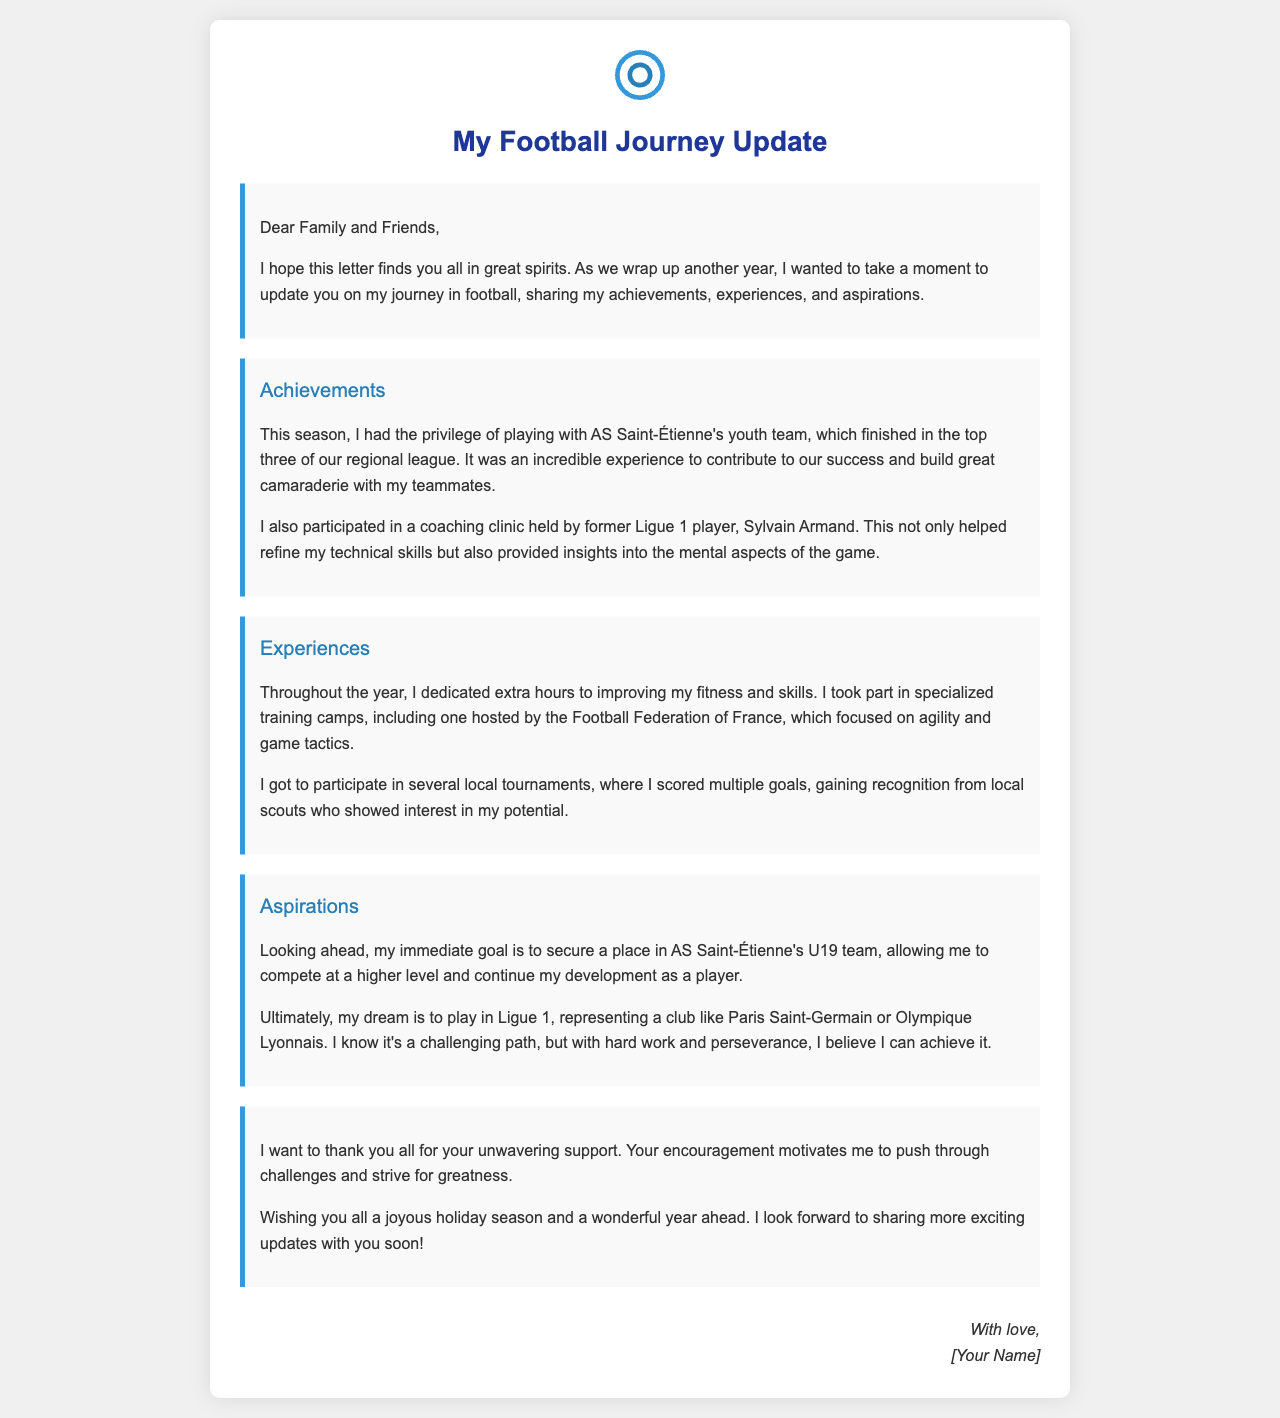What team did you play with this season? The document states that the writer played with AS Saint-Étienne's youth team.
Answer: AS Saint-Étienne What position is the writer aiming for next? The document indicates that the writer's immediate goal is to secure a place in AS Saint-Étienne's U19 team.
Answer: U19 team Who hosted a coaching clinic attended by the writer? The document mentions the coaching clinic was held by former Ligue 1 player Sylvain Armand.
Answer: Sylvain Armand What does the writer aspire to achieve ultimately? The document reveals that the ultimate dream of the writer is to play in Ligue 1.
Answer: Play in Ligue 1 What kind of training camps did the writer participate in? The document describes the specialized training camps focusing on agility and game tactics.
Answer: Specialized training camps What emotion did the writer express towards family and friends? The writer expressed gratitude for the unwavering support received from family and friends.
Answer: Gratitude In what regional league did AS Saint-Étienne's youth team finish? The document states that the team finished in the top three of their regional league.
Answer: Top three What is the writer's personal accomplishment in tournaments this year? The writer gained recognition from local scouts for scoring multiple goals in local tournaments.
Answer: Scoring multiple goals 